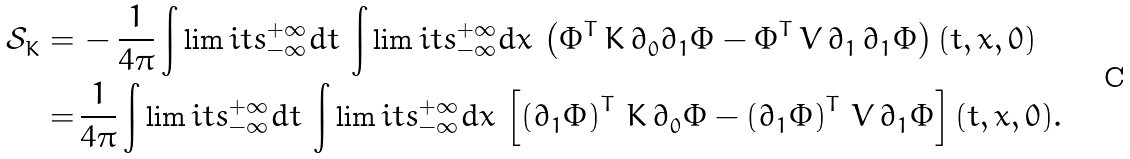<formula> <loc_0><loc_0><loc_500><loc_500>\mathcal { S } ^ { \ } _ { K } = & \, - \frac { 1 } { 4 \pi } \int \lim i t s _ { - \infty } ^ { + \infty } d t \, \int \lim i t s _ { - \infty } ^ { + \infty } d x \, \left ( \Phi ^ { T } \, K \, \partial ^ { \ } _ { 0 } \partial ^ { \ } _ { 1 } \Phi - \Phi ^ { T } \, V \, \partial ^ { \ } _ { 1 } \, \partial ^ { \ } _ { 1 } \Phi \right ) ( t , x , 0 ) \\ = & \, \frac { 1 } { 4 \pi } \int \lim i t s _ { - \infty } ^ { + \infty } d t \, \int \lim i t s _ { - \infty } ^ { + \infty } d x \, \left [ \left ( \partial ^ { \ } _ { 1 } \Phi \right ) ^ { T } \, K \, \partial ^ { \ } _ { 0 } \Phi - \left ( \partial ^ { \ } _ { 1 } \Phi \right ) ^ { T } \, V \, \partial ^ { \ } _ { 1 } \Phi \right ] ( t , x , 0 ) .</formula> 